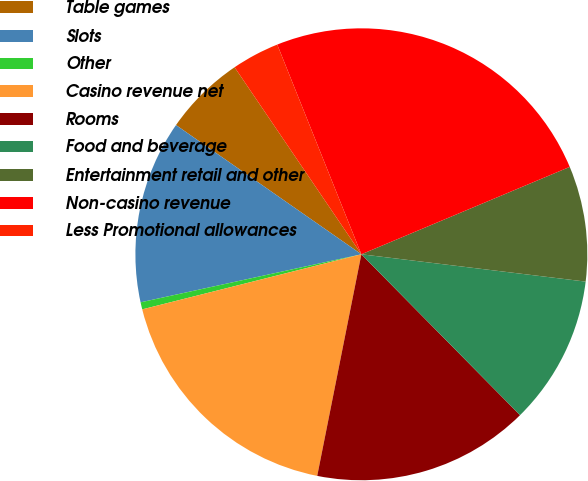Convert chart. <chart><loc_0><loc_0><loc_500><loc_500><pie_chart><fcel>Table games<fcel>Slots<fcel>Other<fcel>Casino revenue net<fcel>Rooms<fcel>Food and beverage<fcel>Entertainment retail and other<fcel>Non-casino revenue<fcel>Less Promotional allowances<nl><fcel>5.83%<fcel>13.1%<fcel>0.51%<fcel>17.95%<fcel>15.52%<fcel>10.68%<fcel>8.25%<fcel>24.75%<fcel>3.41%<nl></chart> 